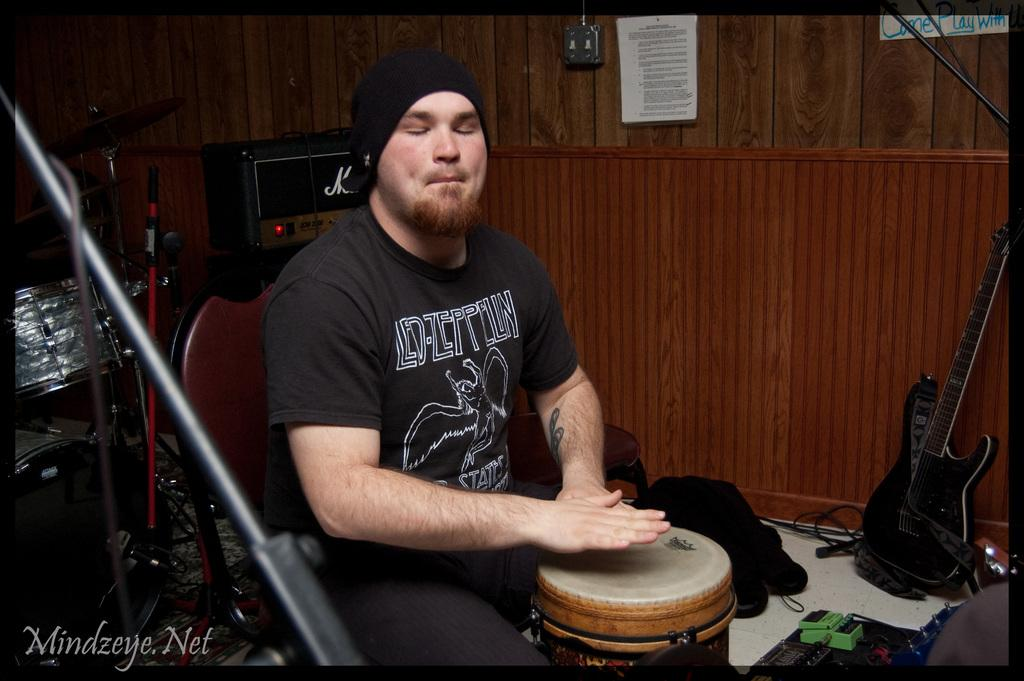What is the man in the image doing? The man is playing drums in the image. What is the man sitting on? The man is sitting on a chair in the image. What other musical instrument is present in the image? There is a guitar in the image. What can be seen connected to the instruments? There are wires in the image. What is the background of the image? There is a wall in the image. What type of wine is the man drinking while playing the drums in the image? There is no wine present in the image; the man is playing drums and sitting on a chair. 